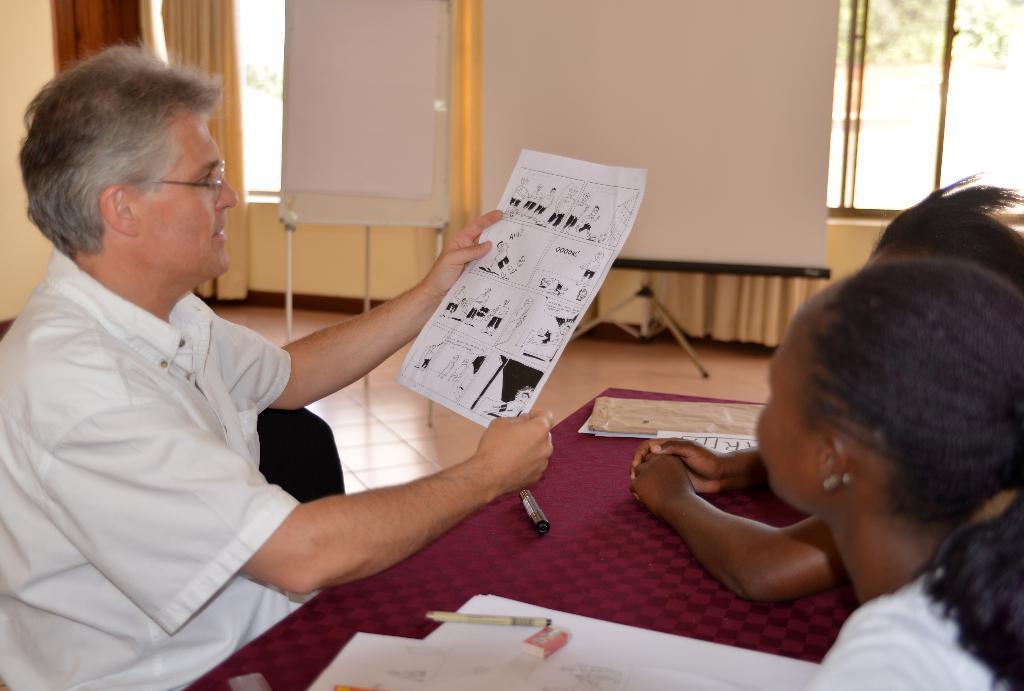How would you summarize this image in a sentence or two? In this image we can see some persons, papers, pens, eraser and other objects. In the background of the image there is a wall, curtains, glass windows, boards and other objects. 